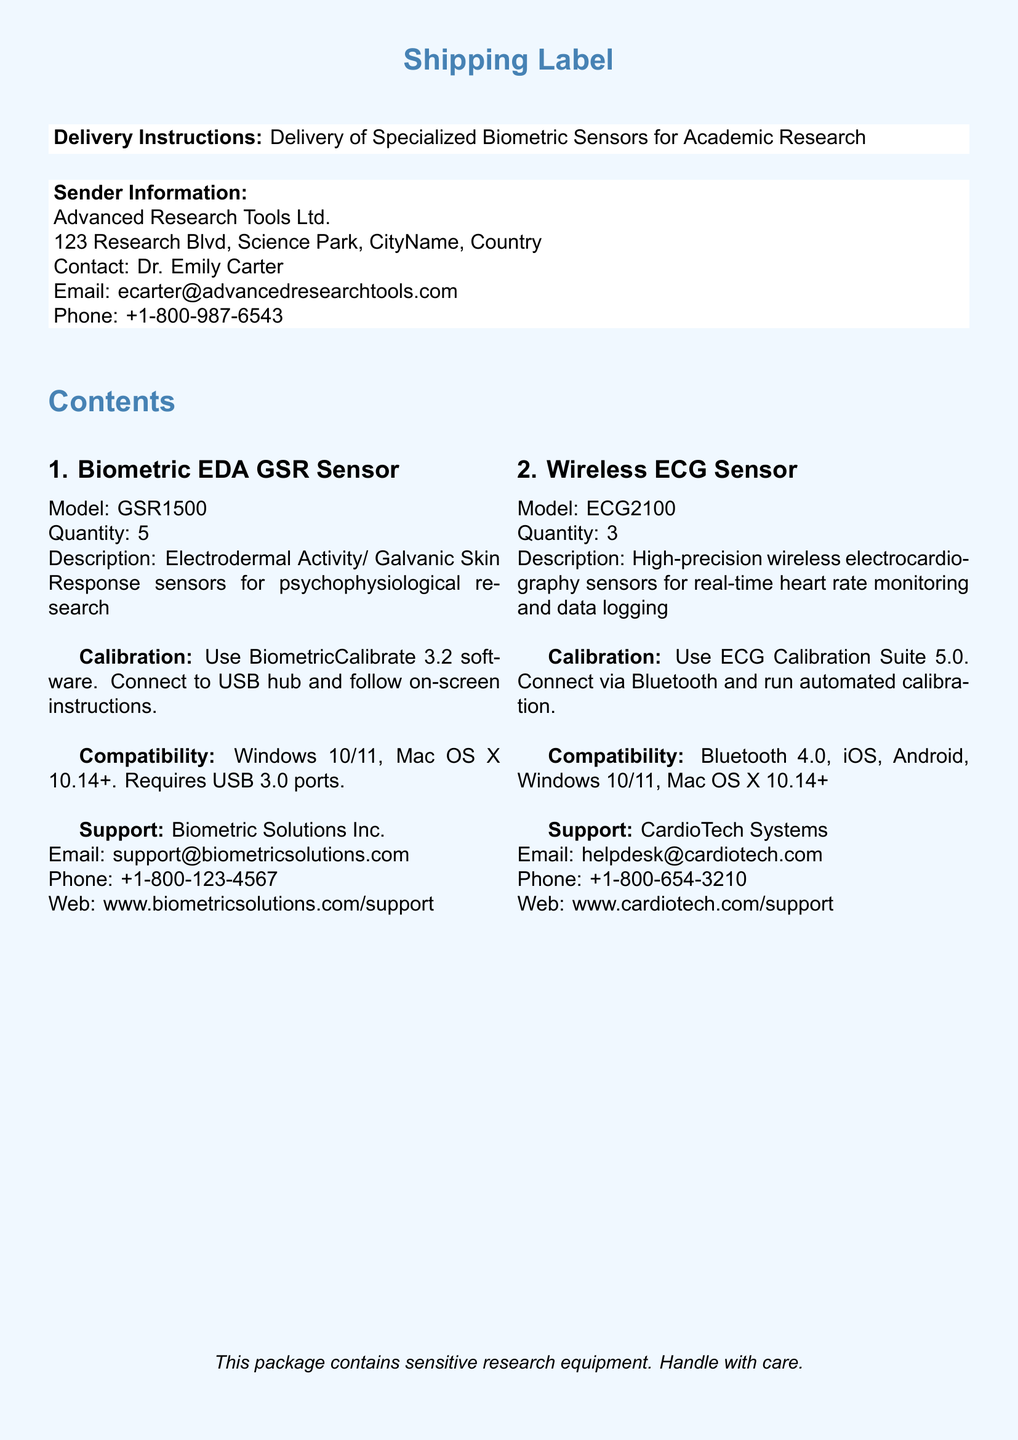What is the sender's name? The sender's name is Dr. Emily Carter, whose contact details are provided in the document.
Answer: Dr. Emily Carter How many Wireless ECG Sensors are included? The number of Wireless ECG Sensors listed in the document indicates the quantity supplied.
Answer: 3 What software is required for calibrating the GSR Sensor? The document specifies "BiometricCalibrate 3.2" as the software needed for calibration.
Answer: BiometricCalibrate 3.2 What is the email for CardioTech Systems support? The document includes the email address for CardioTech Systems, providing support information.
Answer: helpdesk@cardiotech.com What compatibility is required for the GSR Sensor? The document details compatibility requirements, which include operating systems and port specifications.
Answer: Windows 10/11, Mac OS X 10.14+, USB 3.0 How many total sensors are being delivered in this shipment? By adding the quantities specified for each sensor type in the document: 5 GSR sensors and 3 ECG sensors.
Answer: 8 What is the calibration method for the Wireless ECG Sensor? The document describes how to calibrate the Wireless ECG Sensor using Bluetooth and an automated process.
Answer: Connect via Bluetooth and run automated calibration What is the shipping label's purpose? The purpose of a shipping label is primarily to provide information about the contents being delivered, their handling, and support details.
Answer: Delivery of Specialized Biometric Sensors for Academic Research Who should you contact for support regarding the GSR Sensor? The document lists the supporting company and contact details for assistance with the GSR Sensor.
Answer: Biometric Solutions Inc 